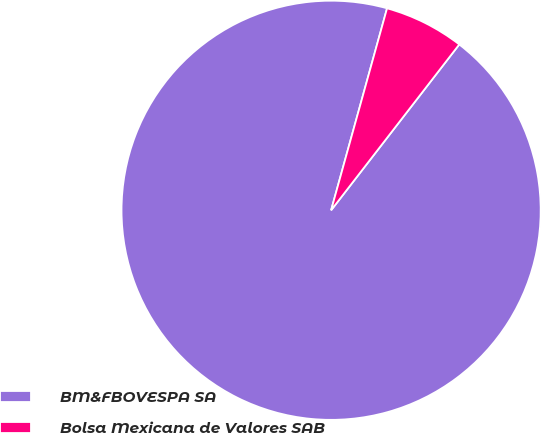Convert chart. <chart><loc_0><loc_0><loc_500><loc_500><pie_chart><fcel>BM&FBOVESPA SA<fcel>Bolsa Mexicana de Valores SAB<nl><fcel>93.83%<fcel>6.17%<nl></chart> 